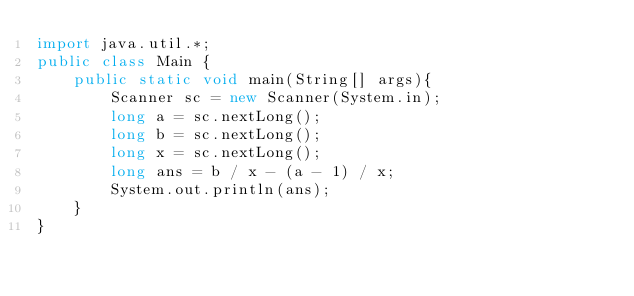<code> <loc_0><loc_0><loc_500><loc_500><_Java_>import java.util.*;
public class Main {
	public static void main(String[] args){
		Scanner sc = new Scanner(System.in);
      	long a = sc.nextLong();
      	long b = sc.nextLong();
      	long x = sc.nextLong();
      	long ans = b / x - (a - 1) / x;
		System.out.println(ans);
	}
}
</code> 